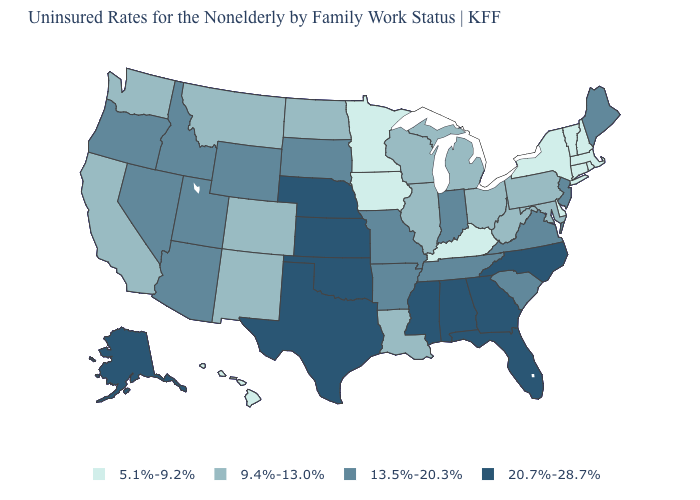Does Mississippi have a higher value than Alaska?
Give a very brief answer. No. Which states hav the highest value in the West?
Keep it brief. Alaska. What is the value of Mississippi?
Be succinct. 20.7%-28.7%. Name the states that have a value in the range 9.4%-13.0%?
Short answer required. California, Colorado, Illinois, Louisiana, Maryland, Michigan, Montana, New Mexico, North Dakota, Ohio, Pennsylvania, Washington, West Virginia, Wisconsin. What is the highest value in states that border Virginia?
Be succinct. 20.7%-28.7%. Which states have the lowest value in the USA?
Be succinct. Connecticut, Delaware, Hawaii, Iowa, Kentucky, Massachusetts, Minnesota, New Hampshire, New York, Rhode Island, Vermont. What is the value of Massachusetts?
Give a very brief answer. 5.1%-9.2%. Does the first symbol in the legend represent the smallest category?
Keep it brief. Yes. Does Hawaii have the lowest value in the West?
Be succinct. Yes. What is the value of Iowa?
Give a very brief answer. 5.1%-9.2%. Among the states that border Washington , which have the lowest value?
Give a very brief answer. Idaho, Oregon. What is the value of Virginia?
Short answer required. 13.5%-20.3%. What is the lowest value in states that border Illinois?
Give a very brief answer. 5.1%-9.2%. Name the states that have a value in the range 9.4%-13.0%?
Give a very brief answer. California, Colorado, Illinois, Louisiana, Maryland, Michigan, Montana, New Mexico, North Dakota, Ohio, Pennsylvania, Washington, West Virginia, Wisconsin. 